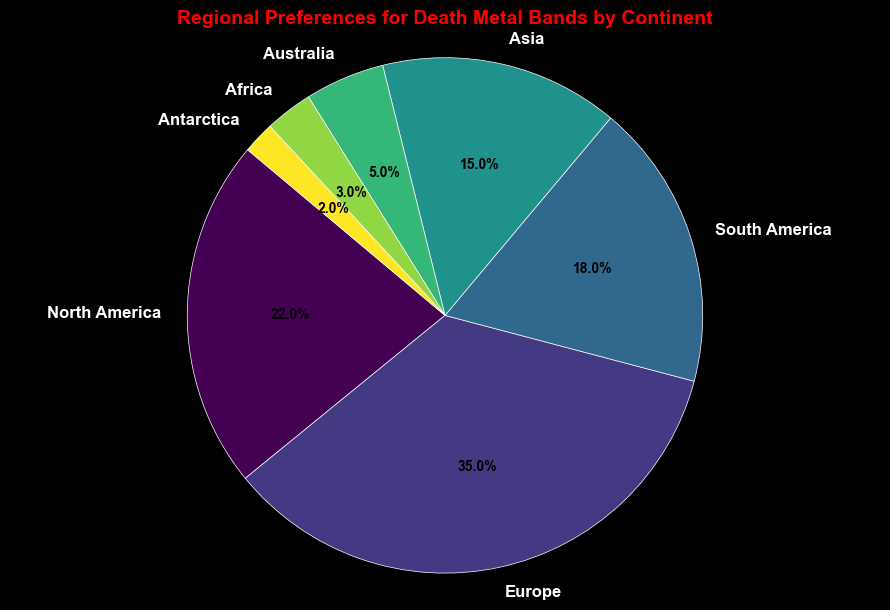What's the total percentage of death metal bands from North America and Europe? To find the total percentage for North America and Europe, add their respective percentages: 22% for North America and 35% for Europe. 22 + 35 = 57
Answer: 57 Which continent has the smallest percentage of death metal bands? Look for the smallest wedge in the pie chart or the smallest value in the data. Antarctica has the smallest percentage at 2%
Answer: Antarctica Which continents have more than 20% of the death metal bands? To determine which continents have more than 20%, look at the wedges that are greater than 20% or the corresponding percentages in the legend. North America (22%) and Europe (35%) both meet this criterion
Answer: North America, Europe What is the percentage difference between South America and Australia? To find the difference, subtract the percentage of Australia from South America’s percentage: 18% (South America) - 5% (Australia) = 13%
Answer: 13 How many continents have percentages in double digits? Look for wedges with values in double digits or review the data for values >= 10%. North America (22%), Europe (35%), South America (18%), and Asia (15%) each have values in double digits. There are 4 such continents
Answer: 4 Which continent contributes the most to the percentage of death metal bands? Identify the largest wedge in the pie chart or the highest percentage in the data. Europe has the highest percentage at 35%
Answer: Europe What's the combined percentage of death metal bands in Asia, Australia, and Africa? Add the percentages of the three continents: 15% (Asia) + 5% (Australia) + 3% (Africa) = 23%
Answer: 23 By how much does the percentage of death metal bands in Asia exceed that in Africa? Subtract Africa’s percentage from Asia’s percentage: 15% (Asia) - 3% (Africa) = 12%
Answer: 12 What percentage of death metal bands is from continents without double-digit percentages? Look for continents with less than 10%: Australia (5%), Africa (3%), and Antarctica (2%). Add these percentages: 5 + 3 + 2 = 10%
Answer: 10 What color is the wedge representing North America? Identify the wedge for North America and note its color. In the code, the color is determined within a viridis colormap, and to visually confirm, North America's wedge appears primarily green
Answer: Green 